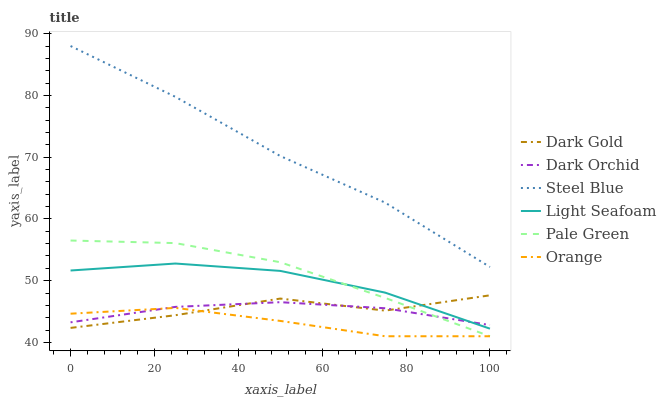Does Orange have the minimum area under the curve?
Answer yes or no. Yes. Does Steel Blue have the maximum area under the curve?
Answer yes or no. Yes. Does Dark Orchid have the minimum area under the curve?
Answer yes or no. No. Does Dark Orchid have the maximum area under the curve?
Answer yes or no. No. Is Dark Orchid the smoothest?
Answer yes or no. Yes. Is Dark Gold the roughest?
Answer yes or no. Yes. Is Steel Blue the smoothest?
Answer yes or no. No. Is Steel Blue the roughest?
Answer yes or no. No. Does Pale Green have the lowest value?
Answer yes or no. Yes. Does Dark Orchid have the lowest value?
Answer yes or no. No. Does Steel Blue have the highest value?
Answer yes or no. Yes. Does Dark Orchid have the highest value?
Answer yes or no. No. Is Dark Orchid less than Steel Blue?
Answer yes or no. Yes. Is Steel Blue greater than Orange?
Answer yes or no. Yes. Does Dark Orchid intersect Dark Gold?
Answer yes or no. Yes. Is Dark Orchid less than Dark Gold?
Answer yes or no. No. Is Dark Orchid greater than Dark Gold?
Answer yes or no. No. Does Dark Orchid intersect Steel Blue?
Answer yes or no. No. 